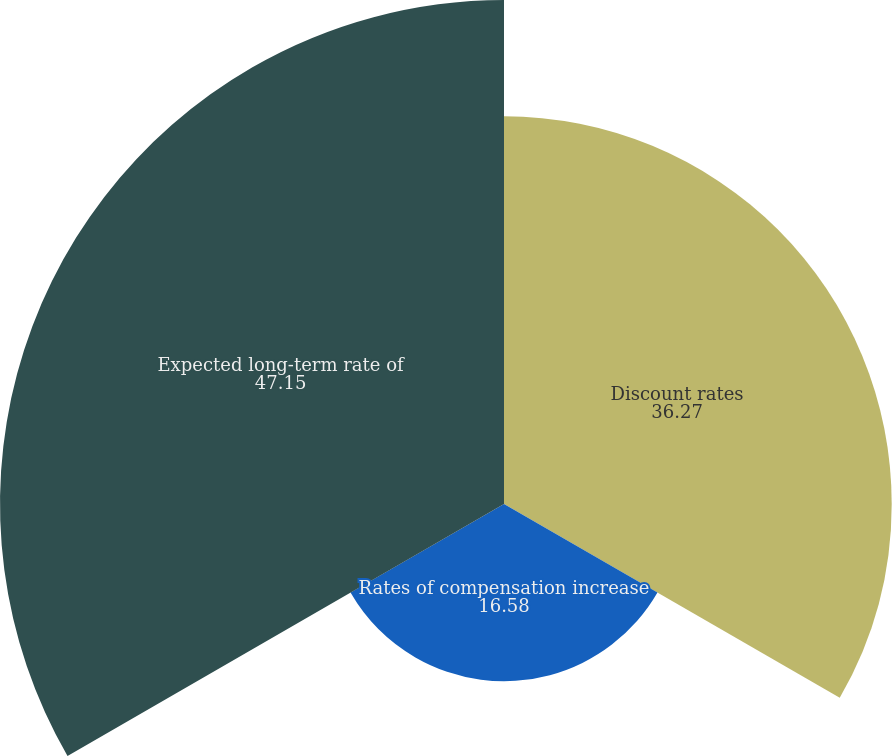Convert chart to OTSL. <chart><loc_0><loc_0><loc_500><loc_500><pie_chart><fcel>Discount rates<fcel>Rates of compensation increase<fcel>Expected long-term rate of<nl><fcel>36.27%<fcel>16.58%<fcel>47.15%<nl></chart> 